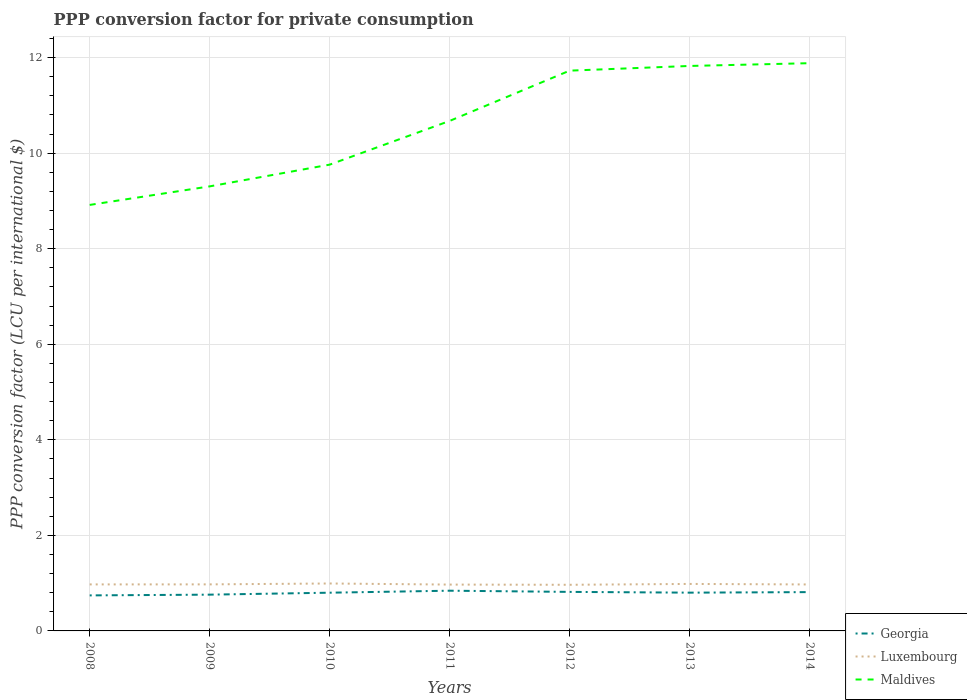Is the number of lines equal to the number of legend labels?
Make the answer very short. Yes. Across all years, what is the maximum PPP conversion factor for private consumption in Luxembourg?
Ensure brevity in your answer.  0.97. In which year was the PPP conversion factor for private consumption in Georgia maximum?
Make the answer very short. 2008. What is the total PPP conversion factor for private consumption in Luxembourg in the graph?
Provide a short and direct response. 0. What is the difference between the highest and the second highest PPP conversion factor for private consumption in Maldives?
Your response must be concise. 2.97. What is the difference between the highest and the lowest PPP conversion factor for private consumption in Georgia?
Offer a terse response. 5. Is the PPP conversion factor for private consumption in Maldives strictly greater than the PPP conversion factor for private consumption in Georgia over the years?
Offer a terse response. No. How many years are there in the graph?
Provide a short and direct response. 7. What is the difference between two consecutive major ticks on the Y-axis?
Provide a short and direct response. 2. Does the graph contain grids?
Make the answer very short. Yes. Where does the legend appear in the graph?
Your response must be concise. Bottom right. How many legend labels are there?
Your answer should be very brief. 3. What is the title of the graph?
Your answer should be very brief. PPP conversion factor for private consumption. Does "Argentina" appear as one of the legend labels in the graph?
Keep it short and to the point. No. What is the label or title of the X-axis?
Your answer should be very brief. Years. What is the label or title of the Y-axis?
Offer a terse response. PPP conversion factor (LCU per international $). What is the PPP conversion factor (LCU per international $) of Georgia in 2008?
Your answer should be very brief. 0.74. What is the PPP conversion factor (LCU per international $) in Luxembourg in 2008?
Give a very brief answer. 0.97. What is the PPP conversion factor (LCU per international $) in Maldives in 2008?
Your response must be concise. 8.92. What is the PPP conversion factor (LCU per international $) in Georgia in 2009?
Offer a terse response. 0.76. What is the PPP conversion factor (LCU per international $) of Luxembourg in 2009?
Offer a terse response. 0.97. What is the PPP conversion factor (LCU per international $) in Maldives in 2009?
Ensure brevity in your answer.  9.31. What is the PPP conversion factor (LCU per international $) in Georgia in 2010?
Provide a succinct answer. 0.8. What is the PPP conversion factor (LCU per international $) of Luxembourg in 2010?
Ensure brevity in your answer.  0.99. What is the PPP conversion factor (LCU per international $) of Maldives in 2010?
Keep it short and to the point. 9.76. What is the PPP conversion factor (LCU per international $) in Georgia in 2011?
Ensure brevity in your answer.  0.84. What is the PPP conversion factor (LCU per international $) in Luxembourg in 2011?
Your answer should be very brief. 0.97. What is the PPP conversion factor (LCU per international $) of Maldives in 2011?
Give a very brief answer. 10.68. What is the PPP conversion factor (LCU per international $) in Georgia in 2012?
Provide a succinct answer. 0.82. What is the PPP conversion factor (LCU per international $) of Luxembourg in 2012?
Give a very brief answer. 0.97. What is the PPP conversion factor (LCU per international $) in Maldives in 2012?
Give a very brief answer. 11.73. What is the PPP conversion factor (LCU per international $) in Georgia in 2013?
Provide a succinct answer. 0.8. What is the PPP conversion factor (LCU per international $) in Luxembourg in 2013?
Your answer should be compact. 0.98. What is the PPP conversion factor (LCU per international $) in Maldives in 2013?
Give a very brief answer. 11.83. What is the PPP conversion factor (LCU per international $) in Georgia in 2014?
Offer a very short reply. 0.81. What is the PPP conversion factor (LCU per international $) in Luxembourg in 2014?
Give a very brief answer. 0.97. What is the PPP conversion factor (LCU per international $) in Maldives in 2014?
Provide a short and direct response. 11.88. Across all years, what is the maximum PPP conversion factor (LCU per international $) in Georgia?
Provide a short and direct response. 0.84. Across all years, what is the maximum PPP conversion factor (LCU per international $) of Luxembourg?
Provide a short and direct response. 0.99. Across all years, what is the maximum PPP conversion factor (LCU per international $) of Maldives?
Offer a terse response. 11.88. Across all years, what is the minimum PPP conversion factor (LCU per international $) in Georgia?
Your answer should be compact. 0.74. Across all years, what is the minimum PPP conversion factor (LCU per international $) in Luxembourg?
Make the answer very short. 0.97. Across all years, what is the minimum PPP conversion factor (LCU per international $) in Maldives?
Ensure brevity in your answer.  8.92. What is the total PPP conversion factor (LCU per international $) in Georgia in the graph?
Offer a terse response. 5.58. What is the total PPP conversion factor (LCU per international $) of Luxembourg in the graph?
Ensure brevity in your answer.  6.83. What is the total PPP conversion factor (LCU per international $) of Maldives in the graph?
Provide a succinct answer. 74.1. What is the difference between the PPP conversion factor (LCU per international $) in Georgia in 2008 and that in 2009?
Keep it short and to the point. -0.02. What is the difference between the PPP conversion factor (LCU per international $) in Luxembourg in 2008 and that in 2009?
Provide a succinct answer. -0. What is the difference between the PPP conversion factor (LCU per international $) of Maldives in 2008 and that in 2009?
Your answer should be very brief. -0.39. What is the difference between the PPP conversion factor (LCU per international $) of Georgia in 2008 and that in 2010?
Offer a terse response. -0.06. What is the difference between the PPP conversion factor (LCU per international $) in Luxembourg in 2008 and that in 2010?
Your answer should be compact. -0.02. What is the difference between the PPP conversion factor (LCU per international $) in Maldives in 2008 and that in 2010?
Your answer should be very brief. -0.84. What is the difference between the PPP conversion factor (LCU per international $) in Georgia in 2008 and that in 2011?
Provide a short and direct response. -0.1. What is the difference between the PPP conversion factor (LCU per international $) of Luxembourg in 2008 and that in 2011?
Provide a succinct answer. 0. What is the difference between the PPP conversion factor (LCU per international $) of Maldives in 2008 and that in 2011?
Keep it short and to the point. -1.76. What is the difference between the PPP conversion factor (LCU per international $) in Georgia in 2008 and that in 2012?
Offer a terse response. -0.07. What is the difference between the PPP conversion factor (LCU per international $) of Luxembourg in 2008 and that in 2012?
Provide a succinct answer. 0.01. What is the difference between the PPP conversion factor (LCU per international $) in Maldives in 2008 and that in 2012?
Your answer should be very brief. -2.81. What is the difference between the PPP conversion factor (LCU per international $) of Georgia in 2008 and that in 2013?
Your response must be concise. -0.06. What is the difference between the PPP conversion factor (LCU per international $) of Luxembourg in 2008 and that in 2013?
Your response must be concise. -0.01. What is the difference between the PPP conversion factor (LCU per international $) in Maldives in 2008 and that in 2013?
Give a very brief answer. -2.91. What is the difference between the PPP conversion factor (LCU per international $) of Georgia in 2008 and that in 2014?
Provide a succinct answer. -0.07. What is the difference between the PPP conversion factor (LCU per international $) of Luxembourg in 2008 and that in 2014?
Offer a very short reply. 0. What is the difference between the PPP conversion factor (LCU per international $) in Maldives in 2008 and that in 2014?
Your response must be concise. -2.97. What is the difference between the PPP conversion factor (LCU per international $) of Georgia in 2009 and that in 2010?
Offer a very short reply. -0.04. What is the difference between the PPP conversion factor (LCU per international $) of Luxembourg in 2009 and that in 2010?
Your answer should be very brief. -0.02. What is the difference between the PPP conversion factor (LCU per international $) of Maldives in 2009 and that in 2010?
Ensure brevity in your answer.  -0.46. What is the difference between the PPP conversion factor (LCU per international $) in Georgia in 2009 and that in 2011?
Ensure brevity in your answer.  -0.08. What is the difference between the PPP conversion factor (LCU per international $) of Luxembourg in 2009 and that in 2011?
Make the answer very short. 0. What is the difference between the PPP conversion factor (LCU per international $) in Maldives in 2009 and that in 2011?
Make the answer very short. -1.37. What is the difference between the PPP conversion factor (LCU per international $) of Georgia in 2009 and that in 2012?
Make the answer very short. -0.06. What is the difference between the PPP conversion factor (LCU per international $) of Luxembourg in 2009 and that in 2012?
Give a very brief answer. 0.01. What is the difference between the PPP conversion factor (LCU per international $) of Maldives in 2009 and that in 2012?
Offer a terse response. -2.42. What is the difference between the PPP conversion factor (LCU per international $) of Georgia in 2009 and that in 2013?
Give a very brief answer. -0.04. What is the difference between the PPP conversion factor (LCU per international $) of Luxembourg in 2009 and that in 2013?
Make the answer very short. -0.01. What is the difference between the PPP conversion factor (LCU per international $) in Maldives in 2009 and that in 2013?
Provide a short and direct response. -2.52. What is the difference between the PPP conversion factor (LCU per international $) in Georgia in 2009 and that in 2014?
Your answer should be very brief. -0.05. What is the difference between the PPP conversion factor (LCU per international $) in Luxembourg in 2009 and that in 2014?
Offer a very short reply. 0. What is the difference between the PPP conversion factor (LCU per international $) of Maldives in 2009 and that in 2014?
Your answer should be compact. -2.58. What is the difference between the PPP conversion factor (LCU per international $) in Georgia in 2010 and that in 2011?
Offer a very short reply. -0.04. What is the difference between the PPP conversion factor (LCU per international $) in Luxembourg in 2010 and that in 2011?
Your response must be concise. 0.02. What is the difference between the PPP conversion factor (LCU per international $) in Maldives in 2010 and that in 2011?
Your answer should be compact. -0.92. What is the difference between the PPP conversion factor (LCU per international $) in Georgia in 2010 and that in 2012?
Your answer should be compact. -0.02. What is the difference between the PPP conversion factor (LCU per international $) of Luxembourg in 2010 and that in 2012?
Give a very brief answer. 0.03. What is the difference between the PPP conversion factor (LCU per international $) of Maldives in 2010 and that in 2012?
Keep it short and to the point. -1.97. What is the difference between the PPP conversion factor (LCU per international $) of Georgia in 2010 and that in 2013?
Provide a succinct answer. -0. What is the difference between the PPP conversion factor (LCU per international $) in Luxembourg in 2010 and that in 2013?
Provide a short and direct response. 0.01. What is the difference between the PPP conversion factor (LCU per international $) in Maldives in 2010 and that in 2013?
Offer a very short reply. -2.07. What is the difference between the PPP conversion factor (LCU per international $) of Georgia in 2010 and that in 2014?
Provide a succinct answer. -0.01. What is the difference between the PPP conversion factor (LCU per international $) of Luxembourg in 2010 and that in 2014?
Make the answer very short. 0.02. What is the difference between the PPP conversion factor (LCU per international $) of Maldives in 2010 and that in 2014?
Keep it short and to the point. -2.12. What is the difference between the PPP conversion factor (LCU per international $) in Georgia in 2011 and that in 2012?
Keep it short and to the point. 0.02. What is the difference between the PPP conversion factor (LCU per international $) in Luxembourg in 2011 and that in 2012?
Provide a short and direct response. 0. What is the difference between the PPP conversion factor (LCU per international $) in Maldives in 2011 and that in 2012?
Your answer should be very brief. -1.05. What is the difference between the PPP conversion factor (LCU per international $) of Georgia in 2011 and that in 2013?
Give a very brief answer. 0.04. What is the difference between the PPP conversion factor (LCU per international $) of Luxembourg in 2011 and that in 2013?
Your answer should be compact. -0.01. What is the difference between the PPP conversion factor (LCU per international $) of Maldives in 2011 and that in 2013?
Keep it short and to the point. -1.15. What is the difference between the PPP conversion factor (LCU per international $) in Georgia in 2011 and that in 2014?
Your answer should be compact. 0.03. What is the difference between the PPP conversion factor (LCU per international $) of Luxembourg in 2011 and that in 2014?
Offer a very short reply. -0. What is the difference between the PPP conversion factor (LCU per international $) of Maldives in 2011 and that in 2014?
Provide a short and direct response. -1.21. What is the difference between the PPP conversion factor (LCU per international $) in Georgia in 2012 and that in 2013?
Give a very brief answer. 0.02. What is the difference between the PPP conversion factor (LCU per international $) in Luxembourg in 2012 and that in 2013?
Provide a succinct answer. -0.02. What is the difference between the PPP conversion factor (LCU per international $) of Maldives in 2012 and that in 2013?
Ensure brevity in your answer.  -0.1. What is the difference between the PPP conversion factor (LCU per international $) in Georgia in 2012 and that in 2014?
Provide a succinct answer. 0. What is the difference between the PPP conversion factor (LCU per international $) of Luxembourg in 2012 and that in 2014?
Your answer should be compact. -0.01. What is the difference between the PPP conversion factor (LCU per international $) in Maldives in 2012 and that in 2014?
Your response must be concise. -0.16. What is the difference between the PPP conversion factor (LCU per international $) in Georgia in 2013 and that in 2014?
Offer a very short reply. -0.01. What is the difference between the PPP conversion factor (LCU per international $) of Luxembourg in 2013 and that in 2014?
Give a very brief answer. 0.01. What is the difference between the PPP conversion factor (LCU per international $) in Maldives in 2013 and that in 2014?
Make the answer very short. -0.06. What is the difference between the PPP conversion factor (LCU per international $) of Georgia in 2008 and the PPP conversion factor (LCU per international $) of Luxembourg in 2009?
Your answer should be compact. -0.23. What is the difference between the PPP conversion factor (LCU per international $) in Georgia in 2008 and the PPP conversion factor (LCU per international $) in Maldives in 2009?
Provide a short and direct response. -8.56. What is the difference between the PPP conversion factor (LCU per international $) in Luxembourg in 2008 and the PPP conversion factor (LCU per international $) in Maldives in 2009?
Provide a succinct answer. -8.33. What is the difference between the PPP conversion factor (LCU per international $) of Georgia in 2008 and the PPP conversion factor (LCU per international $) of Luxembourg in 2010?
Your answer should be compact. -0.25. What is the difference between the PPP conversion factor (LCU per international $) in Georgia in 2008 and the PPP conversion factor (LCU per international $) in Maldives in 2010?
Ensure brevity in your answer.  -9.02. What is the difference between the PPP conversion factor (LCU per international $) of Luxembourg in 2008 and the PPP conversion factor (LCU per international $) of Maldives in 2010?
Your response must be concise. -8.79. What is the difference between the PPP conversion factor (LCU per international $) in Georgia in 2008 and the PPP conversion factor (LCU per international $) in Luxembourg in 2011?
Your answer should be compact. -0.23. What is the difference between the PPP conversion factor (LCU per international $) in Georgia in 2008 and the PPP conversion factor (LCU per international $) in Maldives in 2011?
Your answer should be compact. -9.93. What is the difference between the PPP conversion factor (LCU per international $) in Luxembourg in 2008 and the PPP conversion factor (LCU per international $) in Maldives in 2011?
Offer a terse response. -9.7. What is the difference between the PPP conversion factor (LCU per international $) of Georgia in 2008 and the PPP conversion factor (LCU per international $) of Luxembourg in 2012?
Your answer should be compact. -0.22. What is the difference between the PPP conversion factor (LCU per international $) in Georgia in 2008 and the PPP conversion factor (LCU per international $) in Maldives in 2012?
Make the answer very short. -10.98. What is the difference between the PPP conversion factor (LCU per international $) of Luxembourg in 2008 and the PPP conversion factor (LCU per international $) of Maldives in 2012?
Offer a terse response. -10.75. What is the difference between the PPP conversion factor (LCU per international $) of Georgia in 2008 and the PPP conversion factor (LCU per international $) of Luxembourg in 2013?
Offer a terse response. -0.24. What is the difference between the PPP conversion factor (LCU per international $) of Georgia in 2008 and the PPP conversion factor (LCU per international $) of Maldives in 2013?
Make the answer very short. -11.08. What is the difference between the PPP conversion factor (LCU per international $) of Luxembourg in 2008 and the PPP conversion factor (LCU per international $) of Maldives in 2013?
Provide a succinct answer. -10.85. What is the difference between the PPP conversion factor (LCU per international $) of Georgia in 2008 and the PPP conversion factor (LCU per international $) of Luxembourg in 2014?
Make the answer very short. -0.23. What is the difference between the PPP conversion factor (LCU per international $) of Georgia in 2008 and the PPP conversion factor (LCU per international $) of Maldives in 2014?
Offer a terse response. -11.14. What is the difference between the PPP conversion factor (LCU per international $) of Luxembourg in 2008 and the PPP conversion factor (LCU per international $) of Maldives in 2014?
Make the answer very short. -10.91. What is the difference between the PPP conversion factor (LCU per international $) of Georgia in 2009 and the PPP conversion factor (LCU per international $) of Luxembourg in 2010?
Make the answer very short. -0.23. What is the difference between the PPP conversion factor (LCU per international $) in Georgia in 2009 and the PPP conversion factor (LCU per international $) in Maldives in 2010?
Keep it short and to the point. -9. What is the difference between the PPP conversion factor (LCU per international $) of Luxembourg in 2009 and the PPP conversion factor (LCU per international $) of Maldives in 2010?
Offer a terse response. -8.79. What is the difference between the PPP conversion factor (LCU per international $) in Georgia in 2009 and the PPP conversion factor (LCU per international $) in Luxembourg in 2011?
Keep it short and to the point. -0.21. What is the difference between the PPP conversion factor (LCU per international $) of Georgia in 2009 and the PPP conversion factor (LCU per international $) of Maldives in 2011?
Your answer should be compact. -9.92. What is the difference between the PPP conversion factor (LCU per international $) of Luxembourg in 2009 and the PPP conversion factor (LCU per international $) of Maldives in 2011?
Provide a succinct answer. -9.7. What is the difference between the PPP conversion factor (LCU per international $) of Georgia in 2009 and the PPP conversion factor (LCU per international $) of Luxembourg in 2012?
Give a very brief answer. -0.21. What is the difference between the PPP conversion factor (LCU per international $) of Georgia in 2009 and the PPP conversion factor (LCU per international $) of Maldives in 2012?
Give a very brief answer. -10.97. What is the difference between the PPP conversion factor (LCU per international $) of Luxembourg in 2009 and the PPP conversion factor (LCU per international $) of Maldives in 2012?
Your answer should be compact. -10.75. What is the difference between the PPP conversion factor (LCU per international $) in Georgia in 2009 and the PPP conversion factor (LCU per international $) in Luxembourg in 2013?
Make the answer very short. -0.22. What is the difference between the PPP conversion factor (LCU per international $) of Georgia in 2009 and the PPP conversion factor (LCU per international $) of Maldives in 2013?
Provide a succinct answer. -11.07. What is the difference between the PPP conversion factor (LCU per international $) of Luxembourg in 2009 and the PPP conversion factor (LCU per international $) of Maldives in 2013?
Keep it short and to the point. -10.85. What is the difference between the PPP conversion factor (LCU per international $) of Georgia in 2009 and the PPP conversion factor (LCU per international $) of Luxembourg in 2014?
Provide a short and direct response. -0.21. What is the difference between the PPP conversion factor (LCU per international $) of Georgia in 2009 and the PPP conversion factor (LCU per international $) of Maldives in 2014?
Your answer should be compact. -11.13. What is the difference between the PPP conversion factor (LCU per international $) of Luxembourg in 2009 and the PPP conversion factor (LCU per international $) of Maldives in 2014?
Give a very brief answer. -10.91. What is the difference between the PPP conversion factor (LCU per international $) in Georgia in 2010 and the PPP conversion factor (LCU per international $) in Luxembourg in 2011?
Give a very brief answer. -0.17. What is the difference between the PPP conversion factor (LCU per international $) in Georgia in 2010 and the PPP conversion factor (LCU per international $) in Maldives in 2011?
Provide a succinct answer. -9.88. What is the difference between the PPP conversion factor (LCU per international $) of Luxembourg in 2010 and the PPP conversion factor (LCU per international $) of Maldives in 2011?
Your answer should be compact. -9.68. What is the difference between the PPP conversion factor (LCU per international $) in Georgia in 2010 and the PPP conversion factor (LCU per international $) in Luxembourg in 2012?
Your answer should be compact. -0.17. What is the difference between the PPP conversion factor (LCU per international $) in Georgia in 2010 and the PPP conversion factor (LCU per international $) in Maldives in 2012?
Ensure brevity in your answer.  -10.93. What is the difference between the PPP conversion factor (LCU per international $) in Luxembourg in 2010 and the PPP conversion factor (LCU per international $) in Maldives in 2012?
Keep it short and to the point. -10.74. What is the difference between the PPP conversion factor (LCU per international $) in Georgia in 2010 and the PPP conversion factor (LCU per international $) in Luxembourg in 2013?
Your response must be concise. -0.18. What is the difference between the PPP conversion factor (LCU per international $) of Georgia in 2010 and the PPP conversion factor (LCU per international $) of Maldives in 2013?
Ensure brevity in your answer.  -11.03. What is the difference between the PPP conversion factor (LCU per international $) of Luxembourg in 2010 and the PPP conversion factor (LCU per international $) of Maldives in 2013?
Provide a succinct answer. -10.83. What is the difference between the PPP conversion factor (LCU per international $) of Georgia in 2010 and the PPP conversion factor (LCU per international $) of Luxembourg in 2014?
Offer a terse response. -0.17. What is the difference between the PPP conversion factor (LCU per international $) in Georgia in 2010 and the PPP conversion factor (LCU per international $) in Maldives in 2014?
Your answer should be compact. -11.08. What is the difference between the PPP conversion factor (LCU per international $) in Luxembourg in 2010 and the PPP conversion factor (LCU per international $) in Maldives in 2014?
Provide a short and direct response. -10.89. What is the difference between the PPP conversion factor (LCU per international $) of Georgia in 2011 and the PPP conversion factor (LCU per international $) of Luxembourg in 2012?
Ensure brevity in your answer.  -0.12. What is the difference between the PPP conversion factor (LCU per international $) in Georgia in 2011 and the PPP conversion factor (LCU per international $) in Maldives in 2012?
Your response must be concise. -10.89. What is the difference between the PPP conversion factor (LCU per international $) of Luxembourg in 2011 and the PPP conversion factor (LCU per international $) of Maldives in 2012?
Provide a succinct answer. -10.76. What is the difference between the PPP conversion factor (LCU per international $) of Georgia in 2011 and the PPP conversion factor (LCU per international $) of Luxembourg in 2013?
Your answer should be compact. -0.14. What is the difference between the PPP conversion factor (LCU per international $) of Georgia in 2011 and the PPP conversion factor (LCU per international $) of Maldives in 2013?
Offer a very short reply. -10.98. What is the difference between the PPP conversion factor (LCU per international $) in Luxembourg in 2011 and the PPP conversion factor (LCU per international $) in Maldives in 2013?
Offer a terse response. -10.86. What is the difference between the PPP conversion factor (LCU per international $) of Georgia in 2011 and the PPP conversion factor (LCU per international $) of Luxembourg in 2014?
Ensure brevity in your answer.  -0.13. What is the difference between the PPP conversion factor (LCU per international $) in Georgia in 2011 and the PPP conversion factor (LCU per international $) in Maldives in 2014?
Offer a very short reply. -11.04. What is the difference between the PPP conversion factor (LCU per international $) in Luxembourg in 2011 and the PPP conversion factor (LCU per international $) in Maldives in 2014?
Provide a short and direct response. -10.91. What is the difference between the PPP conversion factor (LCU per international $) of Georgia in 2012 and the PPP conversion factor (LCU per international $) of Luxembourg in 2013?
Offer a very short reply. -0.17. What is the difference between the PPP conversion factor (LCU per international $) in Georgia in 2012 and the PPP conversion factor (LCU per international $) in Maldives in 2013?
Offer a terse response. -11.01. What is the difference between the PPP conversion factor (LCU per international $) in Luxembourg in 2012 and the PPP conversion factor (LCU per international $) in Maldives in 2013?
Make the answer very short. -10.86. What is the difference between the PPP conversion factor (LCU per international $) in Georgia in 2012 and the PPP conversion factor (LCU per international $) in Luxembourg in 2014?
Your answer should be very brief. -0.16. What is the difference between the PPP conversion factor (LCU per international $) of Georgia in 2012 and the PPP conversion factor (LCU per international $) of Maldives in 2014?
Provide a short and direct response. -11.07. What is the difference between the PPP conversion factor (LCU per international $) in Luxembourg in 2012 and the PPP conversion factor (LCU per international $) in Maldives in 2014?
Your response must be concise. -10.92. What is the difference between the PPP conversion factor (LCU per international $) in Georgia in 2013 and the PPP conversion factor (LCU per international $) in Luxembourg in 2014?
Your response must be concise. -0.17. What is the difference between the PPP conversion factor (LCU per international $) in Georgia in 2013 and the PPP conversion factor (LCU per international $) in Maldives in 2014?
Your response must be concise. -11.08. What is the difference between the PPP conversion factor (LCU per international $) of Luxembourg in 2013 and the PPP conversion factor (LCU per international $) of Maldives in 2014?
Make the answer very short. -10.9. What is the average PPP conversion factor (LCU per international $) of Georgia per year?
Provide a short and direct response. 0.8. What is the average PPP conversion factor (LCU per international $) of Luxembourg per year?
Keep it short and to the point. 0.98. What is the average PPP conversion factor (LCU per international $) of Maldives per year?
Offer a very short reply. 10.59. In the year 2008, what is the difference between the PPP conversion factor (LCU per international $) in Georgia and PPP conversion factor (LCU per international $) in Luxembourg?
Offer a terse response. -0.23. In the year 2008, what is the difference between the PPP conversion factor (LCU per international $) in Georgia and PPP conversion factor (LCU per international $) in Maldives?
Your response must be concise. -8.17. In the year 2008, what is the difference between the PPP conversion factor (LCU per international $) in Luxembourg and PPP conversion factor (LCU per international $) in Maldives?
Provide a succinct answer. -7.94. In the year 2009, what is the difference between the PPP conversion factor (LCU per international $) in Georgia and PPP conversion factor (LCU per international $) in Luxembourg?
Your answer should be very brief. -0.22. In the year 2009, what is the difference between the PPP conversion factor (LCU per international $) of Georgia and PPP conversion factor (LCU per international $) of Maldives?
Your response must be concise. -8.55. In the year 2009, what is the difference between the PPP conversion factor (LCU per international $) of Luxembourg and PPP conversion factor (LCU per international $) of Maldives?
Your answer should be compact. -8.33. In the year 2010, what is the difference between the PPP conversion factor (LCU per international $) in Georgia and PPP conversion factor (LCU per international $) in Luxembourg?
Offer a very short reply. -0.19. In the year 2010, what is the difference between the PPP conversion factor (LCU per international $) in Georgia and PPP conversion factor (LCU per international $) in Maldives?
Offer a very short reply. -8.96. In the year 2010, what is the difference between the PPP conversion factor (LCU per international $) in Luxembourg and PPP conversion factor (LCU per international $) in Maldives?
Your answer should be compact. -8.77. In the year 2011, what is the difference between the PPP conversion factor (LCU per international $) in Georgia and PPP conversion factor (LCU per international $) in Luxembourg?
Provide a succinct answer. -0.13. In the year 2011, what is the difference between the PPP conversion factor (LCU per international $) in Georgia and PPP conversion factor (LCU per international $) in Maldives?
Your response must be concise. -9.83. In the year 2011, what is the difference between the PPP conversion factor (LCU per international $) of Luxembourg and PPP conversion factor (LCU per international $) of Maldives?
Provide a short and direct response. -9.71. In the year 2012, what is the difference between the PPP conversion factor (LCU per international $) in Georgia and PPP conversion factor (LCU per international $) in Luxembourg?
Keep it short and to the point. -0.15. In the year 2012, what is the difference between the PPP conversion factor (LCU per international $) in Georgia and PPP conversion factor (LCU per international $) in Maldives?
Give a very brief answer. -10.91. In the year 2012, what is the difference between the PPP conversion factor (LCU per international $) of Luxembourg and PPP conversion factor (LCU per international $) of Maldives?
Your answer should be compact. -10.76. In the year 2013, what is the difference between the PPP conversion factor (LCU per international $) of Georgia and PPP conversion factor (LCU per international $) of Luxembourg?
Your answer should be very brief. -0.18. In the year 2013, what is the difference between the PPP conversion factor (LCU per international $) of Georgia and PPP conversion factor (LCU per international $) of Maldives?
Offer a very short reply. -11.03. In the year 2013, what is the difference between the PPP conversion factor (LCU per international $) in Luxembourg and PPP conversion factor (LCU per international $) in Maldives?
Your answer should be compact. -10.84. In the year 2014, what is the difference between the PPP conversion factor (LCU per international $) in Georgia and PPP conversion factor (LCU per international $) in Luxembourg?
Provide a short and direct response. -0.16. In the year 2014, what is the difference between the PPP conversion factor (LCU per international $) in Georgia and PPP conversion factor (LCU per international $) in Maldives?
Provide a short and direct response. -11.07. In the year 2014, what is the difference between the PPP conversion factor (LCU per international $) of Luxembourg and PPP conversion factor (LCU per international $) of Maldives?
Offer a very short reply. -10.91. What is the ratio of the PPP conversion factor (LCU per international $) of Georgia in 2008 to that in 2009?
Your answer should be very brief. 0.98. What is the ratio of the PPP conversion factor (LCU per international $) in Maldives in 2008 to that in 2009?
Provide a succinct answer. 0.96. What is the ratio of the PPP conversion factor (LCU per international $) in Georgia in 2008 to that in 2010?
Offer a very short reply. 0.93. What is the ratio of the PPP conversion factor (LCU per international $) of Luxembourg in 2008 to that in 2010?
Your response must be concise. 0.98. What is the ratio of the PPP conversion factor (LCU per international $) of Maldives in 2008 to that in 2010?
Offer a terse response. 0.91. What is the ratio of the PPP conversion factor (LCU per international $) in Georgia in 2008 to that in 2011?
Ensure brevity in your answer.  0.88. What is the ratio of the PPP conversion factor (LCU per international $) of Maldives in 2008 to that in 2011?
Keep it short and to the point. 0.84. What is the ratio of the PPP conversion factor (LCU per international $) of Georgia in 2008 to that in 2012?
Your answer should be compact. 0.91. What is the ratio of the PPP conversion factor (LCU per international $) of Luxembourg in 2008 to that in 2012?
Your answer should be compact. 1.01. What is the ratio of the PPP conversion factor (LCU per international $) in Maldives in 2008 to that in 2012?
Your answer should be very brief. 0.76. What is the ratio of the PPP conversion factor (LCU per international $) of Georgia in 2008 to that in 2013?
Keep it short and to the point. 0.93. What is the ratio of the PPP conversion factor (LCU per international $) in Maldives in 2008 to that in 2013?
Provide a short and direct response. 0.75. What is the ratio of the PPP conversion factor (LCU per international $) of Georgia in 2008 to that in 2014?
Provide a succinct answer. 0.92. What is the ratio of the PPP conversion factor (LCU per international $) of Luxembourg in 2008 to that in 2014?
Ensure brevity in your answer.  1. What is the ratio of the PPP conversion factor (LCU per international $) of Maldives in 2008 to that in 2014?
Provide a succinct answer. 0.75. What is the ratio of the PPP conversion factor (LCU per international $) in Georgia in 2009 to that in 2010?
Ensure brevity in your answer.  0.95. What is the ratio of the PPP conversion factor (LCU per international $) of Luxembourg in 2009 to that in 2010?
Give a very brief answer. 0.98. What is the ratio of the PPP conversion factor (LCU per international $) in Maldives in 2009 to that in 2010?
Your answer should be very brief. 0.95. What is the ratio of the PPP conversion factor (LCU per international $) in Georgia in 2009 to that in 2011?
Your answer should be compact. 0.9. What is the ratio of the PPP conversion factor (LCU per international $) in Luxembourg in 2009 to that in 2011?
Your response must be concise. 1. What is the ratio of the PPP conversion factor (LCU per international $) in Maldives in 2009 to that in 2011?
Keep it short and to the point. 0.87. What is the ratio of the PPP conversion factor (LCU per international $) in Georgia in 2009 to that in 2012?
Offer a terse response. 0.93. What is the ratio of the PPP conversion factor (LCU per international $) of Maldives in 2009 to that in 2012?
Ensure brevity in your answer.  0.79. What is the ratio of the PPP conversion factor (LCU per international $) of Georgia in 2009 to that in 2013?
Ensure brevity in your answer.  0.95. What is the ratio of the PPP conversion factor (LCU per international $) of Maldives in 2009 to that in 2013?
Provide a short and direct response. 0.79. What is the ratio of the PPP conversion factor (LCU per international $) in Georgia in 2009 to that in 2014?
Offer a very short reply. 0.93. What is the ratio of the PPP conversion factor (LCU per international $) in Luxembourg in 2009 to that in 2014?
Provide a succinct answer. 1. What is the ratio of the PPP conversion factor (LCU per international $) of Maldives in 2009 to that in 2014?
Your answer should be very brief. 0.78. What is the ratio of the PPP conversion factor (LCU per international $) in Georgia in 2010 to that in 2011?
Make the answer very short. 0.95. What is the ratio of the PPP conversion factor (LCU per international $) of Luxembourg in 2010 to that in 2011?
Provide a short and direct response. 1.02. What is the ratio of the PPP conversion factor (LCU per international $) of Maldives in 2010 to that in 2011?
Your response must be concise. 0.91. What is the ratio of the PPP conversion factor (LCU per international $) in Georgia in 2010 to that in 2012?
Your response must be concise. 0.98. What is the ratio of the PPP conversion factor (LCU per international $) in Luxembourg in 2010 to that in 2012?
Offer a very short reply. 1.03. What is the ratio of the PPP conversion factor (LCU per international $) of Maldives in 2010 to that in 2012?
Your response must be concise. 0.83. What is the ratio of the PPP conversion factor (LCU per international $) in Georgia in 2010 to that in 2013?
Keep it short and to the point. 1. What is the ratio of the PPP conversion factor (LCU per international $) in Luxembourg in 2010 to that in 2013?
Your answer should be compact. 1.01. What is the ratio of the PPP conversion factor (LCU per international $) in Maldives in 2010 to that in 2013?
Ensure brevity in your answer.  0.83. What is the ratio of the PPP conversion factor (LCU per international $) of Georgia in 2010 to that in 2014?
Give a very brief answer. 0.98. What is the ratio of the PPP conversion factor (LCU per international $) of Maldives in 2010 to that in 2014?
Provide a succinct answer. 0.82. What is the ratio of the PPP conversion factor (LCU per international $) of Georgia in 2011 to that in 2012?
Keep it short and to the point. 1.03. What is the ratio of the PPP conversion factor (LCU per international $) in Maldives in 2011 to that in 2012?
Provide a short and direct response. 0.91. What is the ratio of the PPP conversion factor (LCU per international $) of Georgia in 2011 to that in 2013?
Make the answer very short. 1.05. What is the ratio of the PPP conversion factor (LCU per international $) of Luxembourg in 2011 to that in 2013?
Keep it short and to the point. 0.99. What is the ratio of the PPP conversion factor (LCU per international $) in Maldives in 2011 to that in 2013?
Your response must be concise. 0.9. What is the ratio of the PPP conversion factor (LCU per international $) of Georgia in 2011 to that in 2014?
Provide a short and direct response. 1.04. What is the ratio of the PPP conversion factor (LCU per international $) in Luxembourg in 2011 to that in 2014?
Keep it short and to the point. 1. What is the ratio of the PPP conversion factor (LCU per international $) of Maldives in 2011 to that in 2014?
Make the answer very short. 0.9. What is the ratio of the PPP conversion factor (LCU per international $) in Georgia in 2012 to that in 2013?
Ensure brevity in your answer.  1.02. What is the ratio of the PPP conversion factor (LCU per international $) of Luxembourg in 2012 to that in 2013?
Provide a short and direct response. 0.98. What is the ratio of the PPP conversion factor (LCU per international $) in Maldives in 2012 to that in 2013?
Give a very brief answer. 0.99. What is the ratio of the PPP conversion factor (LCU per international $) in Georgia in 2012 to that in 2014?
Your response must be concise. 1.01. What is the ratio of the PPP conversion factor (LCU per international $) of Maldives in 2012 to that in 2014?
Ensure brevity in your answer.  0.99. What is the ratio of the PPP conversion factor (LCU per international $) of Georgia in 2013 to that in 2014?
Your answer should be very brief. 0.99. What is the ratio of the PPP conversion factor (LCU per international $) in Luxembourg in 2013 to that in 2014?
Provide a short and direct response. 1.01. What is the difference between the highest and the second highest PPP conversion factor (LCU per international $) in Georgia?
Ensure brevity in your answer.  0.02. What is the difference between the highest and the second highest PPP conversion factor (LCU per international $) of Luxembourg?
Your answer should be very brief. 0.01. What is the difference between the highest and the second highest PPP conversion factor (LCU per international $) of Maldives?
Offer a very short reply. 0.06. What is the difference between the highest and the lowest PPP conversion factor (LCU per international $) of Georgia?
Offer a very short reply. 0.1. What is the difference between the highest and the lowest PPP conversion factor (LCU per international $) in Luxembourg?
Provide a succinct answer. 0.03. What is the difference between the highest and the lowest PPP conversion factor (LCU per international $) of Maldives?
Offer a terse response. 2.97. 